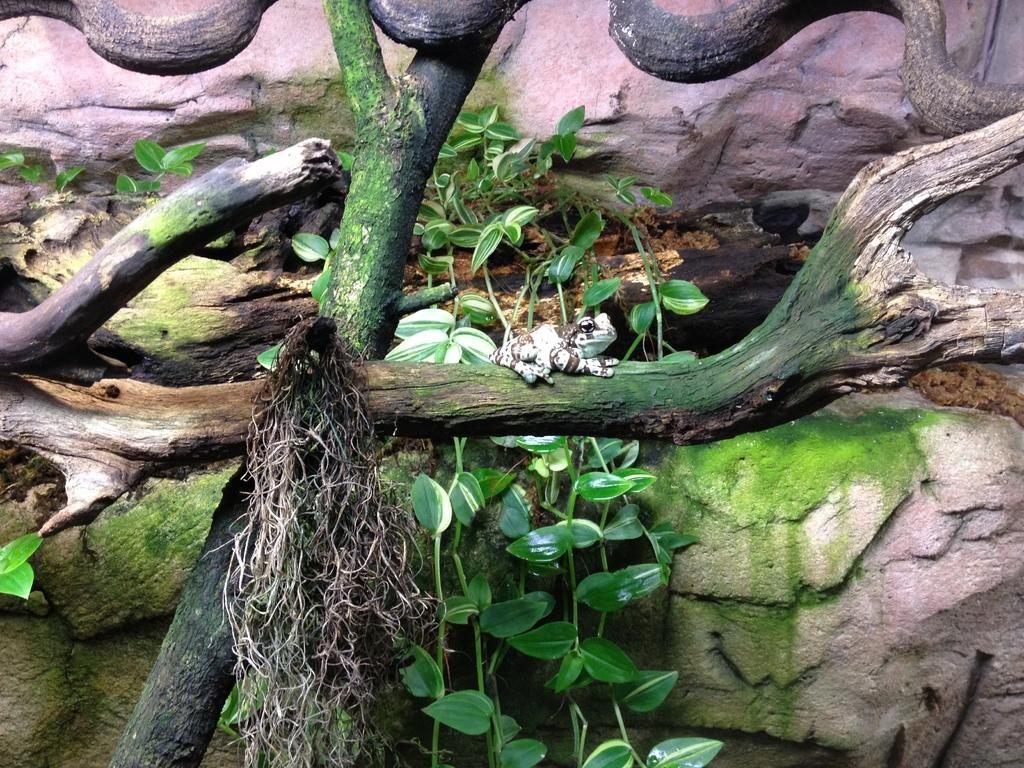What animal can be seen in the picture? There is a frog in the picture. Where is the frog located? The frog is sitting on a tree trunk. What type of vegetation is present in the picture? There are leaves in the picture. What other natural elements can be seen in the image? There are rocks in the picture. How many children are playing with the structure in the picture? There is no structure or children present in the image; it features a frog sitting on a tree trunk with leaves and rocks nearby. 